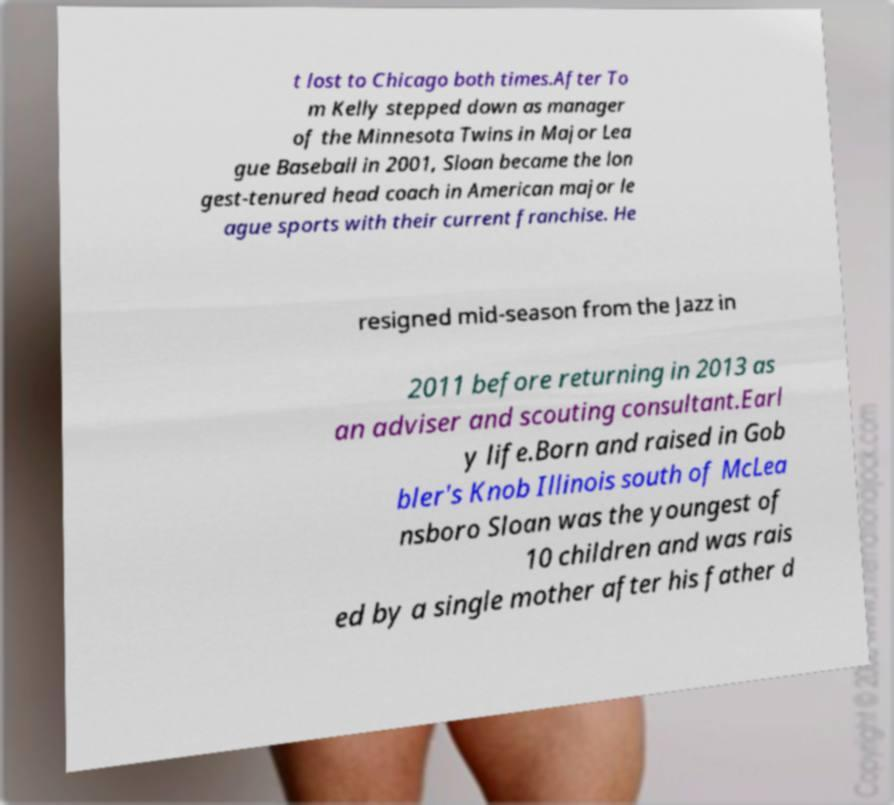What messages or text are displayed in this image? I need them in a readable, typed format. t lost to Chicago both times.After To m Kelly stepped down as manager of the Minnesota Twins in Major Lea gue Baseball in 2001, Sloan became the lon gest-tenured head coach in American major le ague sports with their current franchise. He resigned mid-season from the Jazz in 2011 before returning in 2013 as an adviser and scouting consultant.Earl y life.Born and raised in Gob bler's Knob Illinois south of McLea nsboro Sloan was the youngest of 10 children and was rais ed by a single mother after his father d 